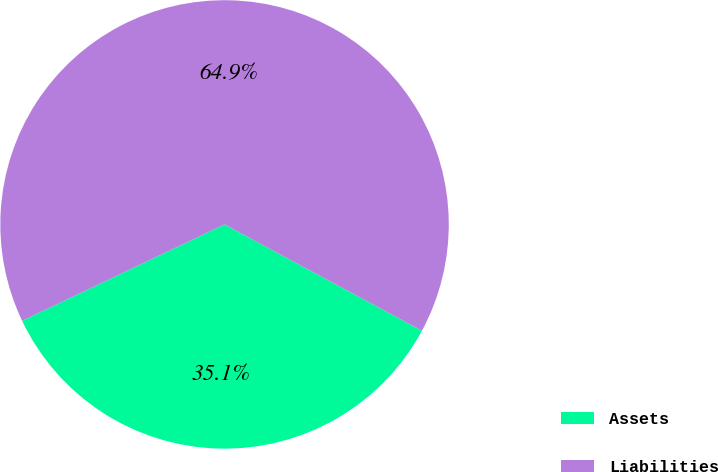Convert chart to OTSL. <chart><loc_0><loc_0><loc_500><loc_500><pie_chart><fcel>Assets<fcel>Liabilities<nl><fcel>35.06%<fcel>64.94%<nl></chart> 